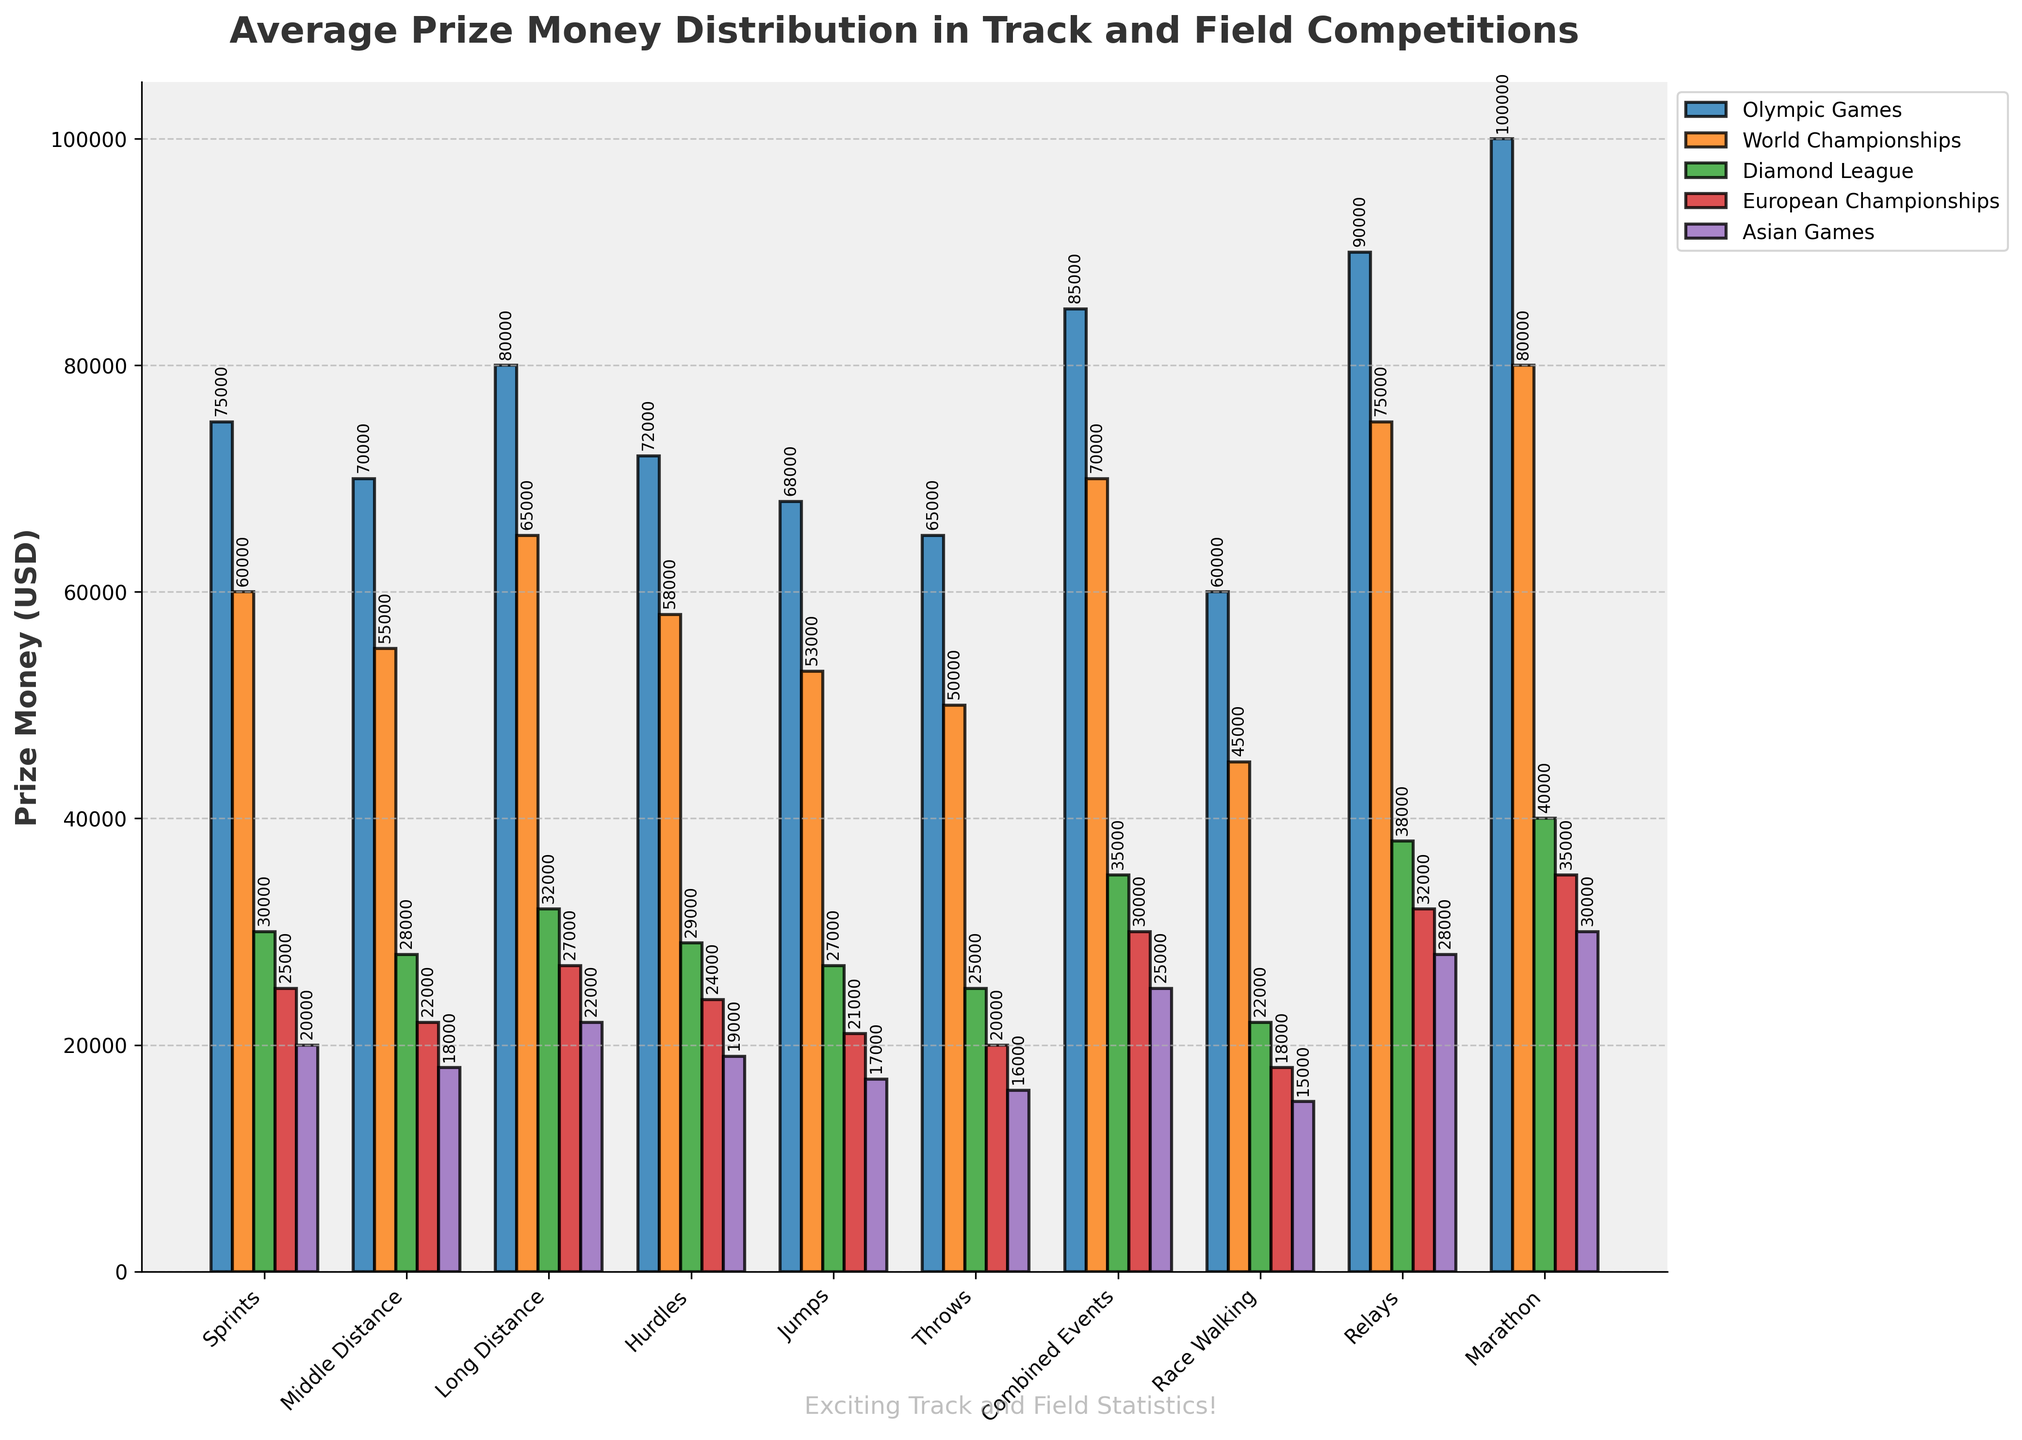What's the average prize money for Sprints across all competitions? To calculate the average prize money for Sprints, sum the prize money values for all competitions: 75000 (Olympic Games) + 60000 (World Championships) + 30000 (Diamond League) + 25000 (European Championships) + 20000 (Asian Games) = 210000. Then, divide by the number of competitions, which is 5. So, the average is 210000 / 5 = 42000
Answer: 42000 Which event type has the highest prize money in the Marathon competition? The chart shows the bars for different event types in the Marathon competition. The tallest bar represents the prize money for Marathon under the "Marathon" event type, which is 100000
Answer: Marathon How much more prize money does the Olympic Games offer compared to Diamond League for Combined Events? The prize money for Combined Events in the Olympic Games is 85000, and in the Diamond League, it is 35000. The difference is 85000 - 35000 = 50000
Answer: 50000 Which competition offers the least prize money for Race Walking, and what is the amount? The bar corresponding to the Asian Games for Race Walking is the shortest, representing the lowest prize money amount, which is 15000
Answer: Asian Games, 15000 What is the total prize money for the Relays event in European Championships and Asian Games combined? The prize money for Relays in the European Championships is 32000, and in the Asian Games, it is 28000. Summing them up gives 32000 + 28000 = 60000
Answer: 60000 Which competition generally offers the highest prize money across all event types? By observing the highest bars across different event types, we can see that the Olympic Games frequently offer the highest prize money in most event types
Answer: Olympic Games Between the World Championships and Diamond League, which competition offers more prize money for Long Distance, and by how much? For Long Distance, the World Championships offer 65000, and the Diamond League offers 32000. The difference is 65000 - 32000 = 33000
Answer: World Championships, 33000 What's the total prize money distribution for Jumps across all competitions? Add the prize money values for Jumps in all competitions: 68000 (Olympic Games) + 53000 (World Championships) + 27000 (Diamond League) + 21000 (European Championships) + 17000 (Asian Games) = 186000
Answer: 186000 Which event type has the smallest range in prize money across all competitions? The event type with the smallest range is found by considering the maximum and minimum prize money for each event type: the range is largest for Marathon (100000 - 30000) and smallest for Race Walking (60000 - 15000). Calculated ranges are: Sprints (75000-20000)=55000, Middle Distance (70000-18000)=52000, Long Distance (80000-22000)=58000, Hurdles (72000-19000)=53000, Jumps (68000-17000)=51000, Throws (65000-16000)=49000, Combined Events (85000-25000)=60000, Race Walking (60000-15000)=45000, Relays (90000-28000)=62000, Marathon (100000-30000)=70000. So, the smallest range is 45000 for Race Walking
Answer: Race Walking, 45000 Which prizes are higher in amount for Jumps, European Championships, or Asian Games, and by how much? The prize money for Jumps in the European Championships is 21000, while in the Asian Games, it is 17000. The difference is 21000 - 17000 = 4000
Answer: European Championships, 4000 